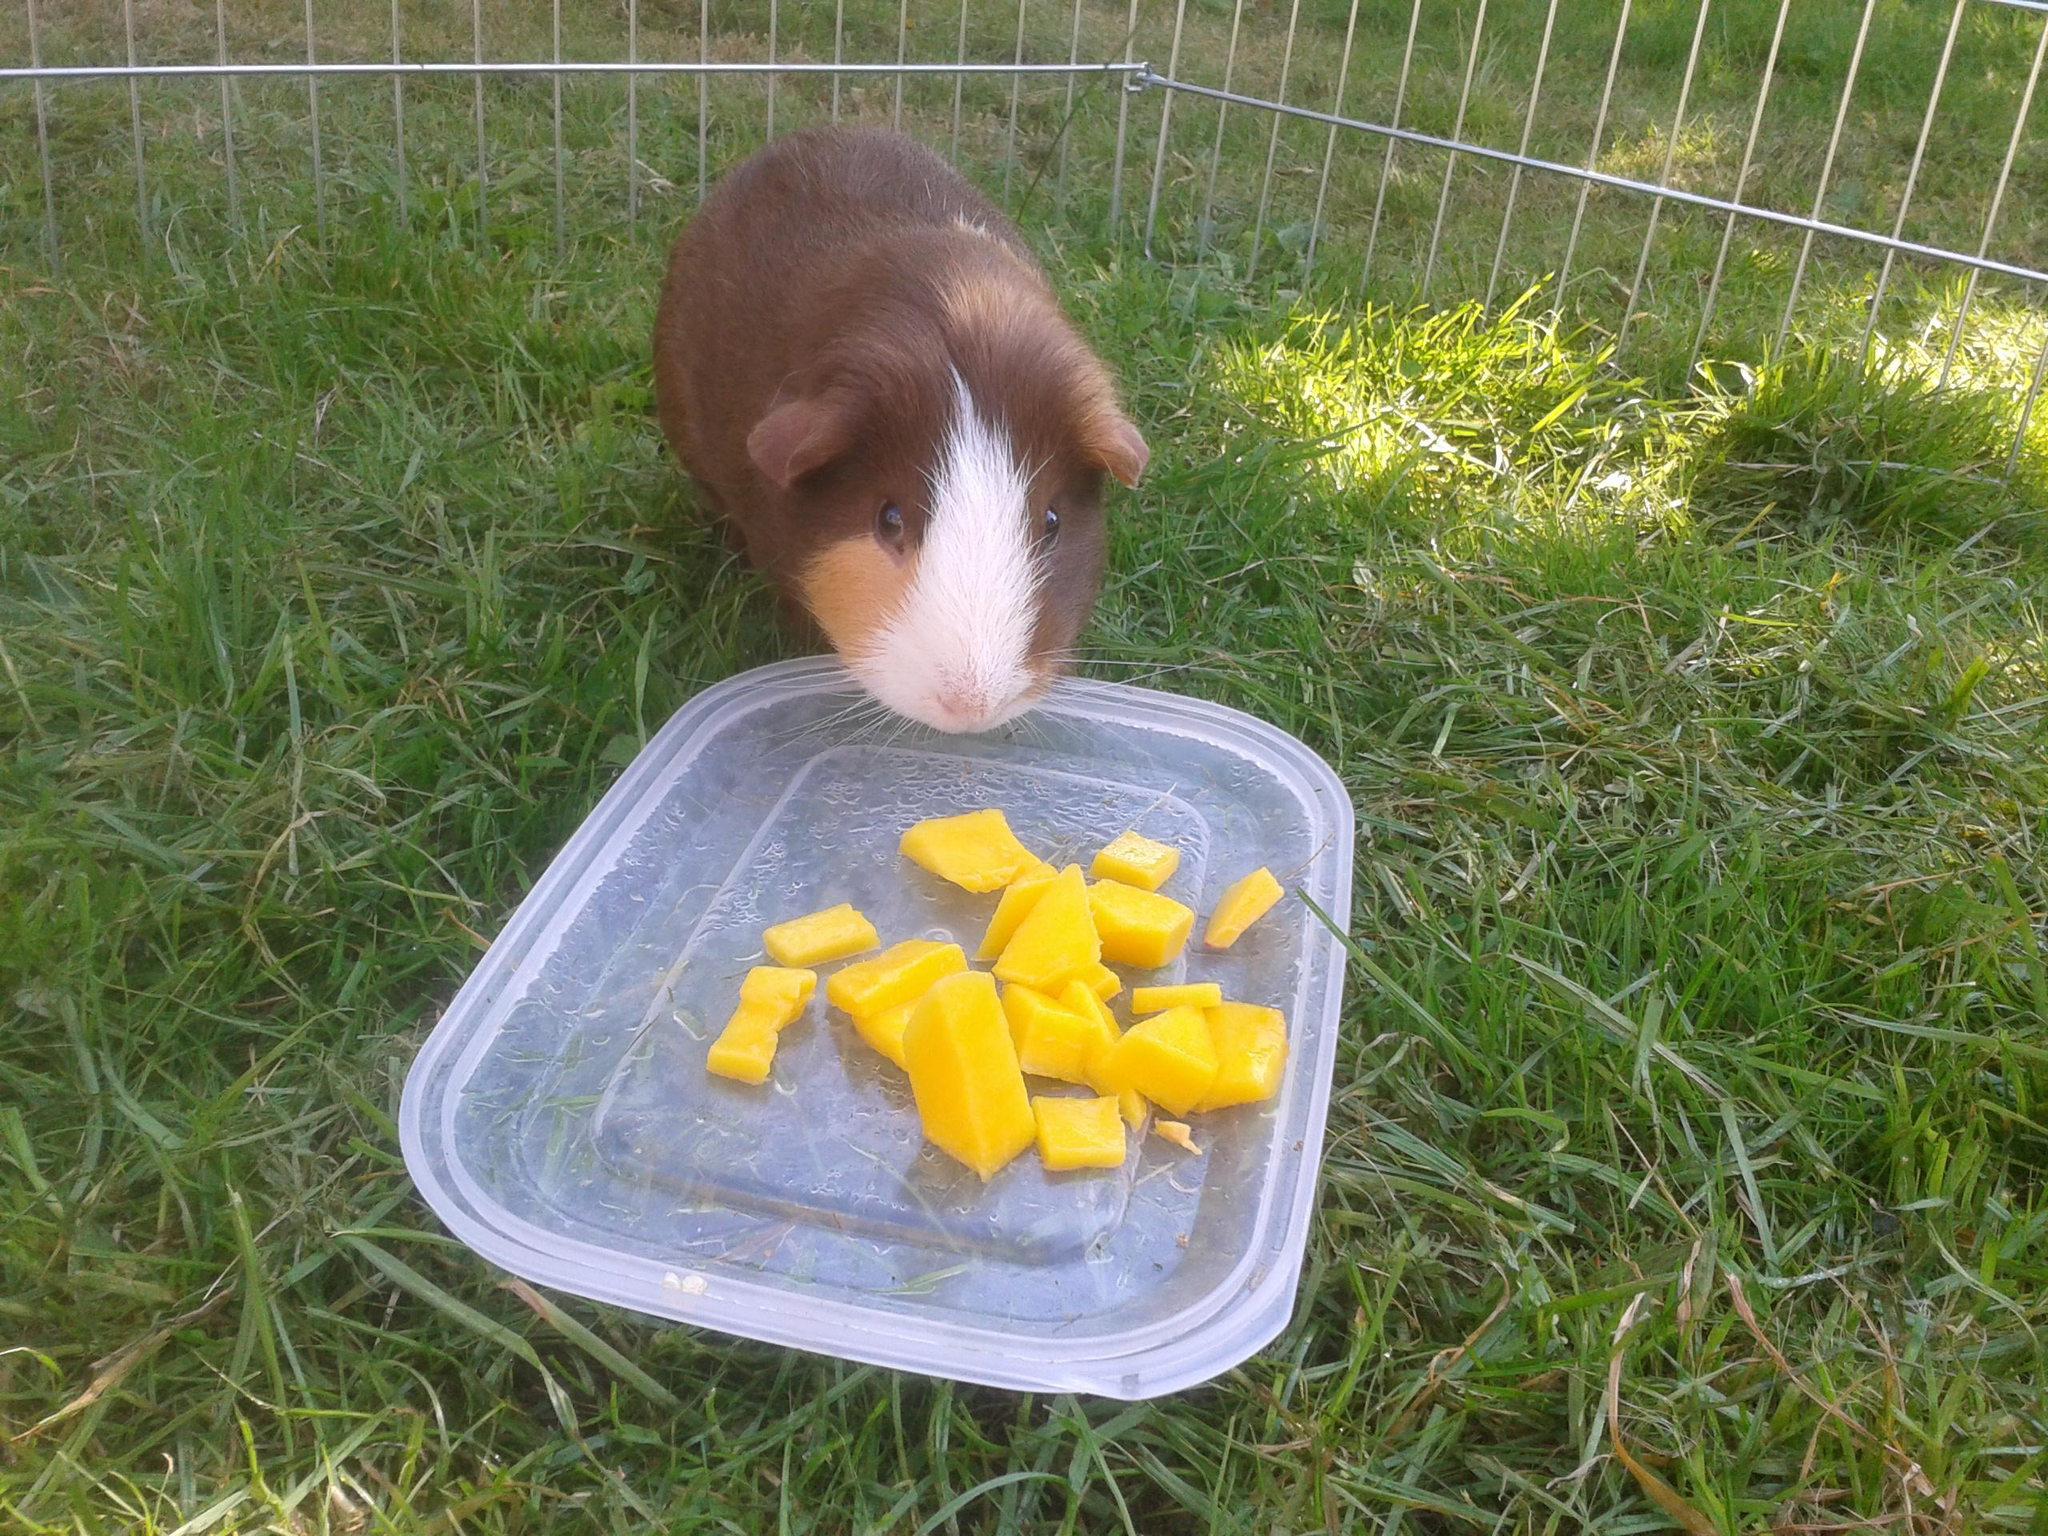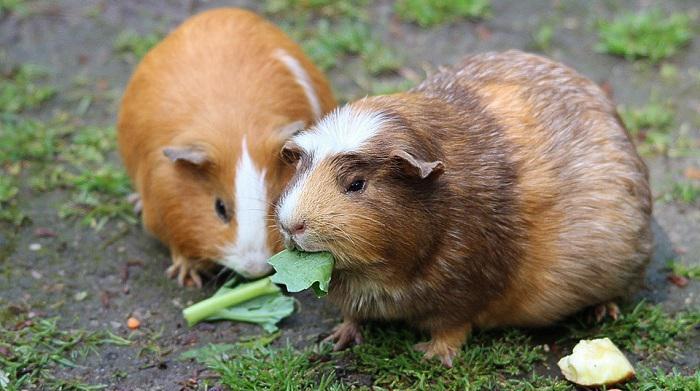The first image is the image on the left, the second image is the image on the right. Given the left and right images, does the statement "In at least one of the pictures, at least one guinea pig is eating" hold true? Answer yes or no. Yes. The first image is the image on the left, the second image is the image on the right. For the images shown, is this caption "One of the images shows exactly two guinea pigs." true? Answer yes or no. Yes. The first image is the image on the left, the second image is the image on the right. Assess this claim about the two images: "There is exactly one animal in the image on the left". Correct or not? Answer yes or no. Yes. The first image is the image on the left, the second image is the image on the right. Assess this claim about the two images: "One image shows a little animal with a white nose in a grassy area near some fruit it has been given to eat.". Correct or not? Answer yes or no. Yes. 